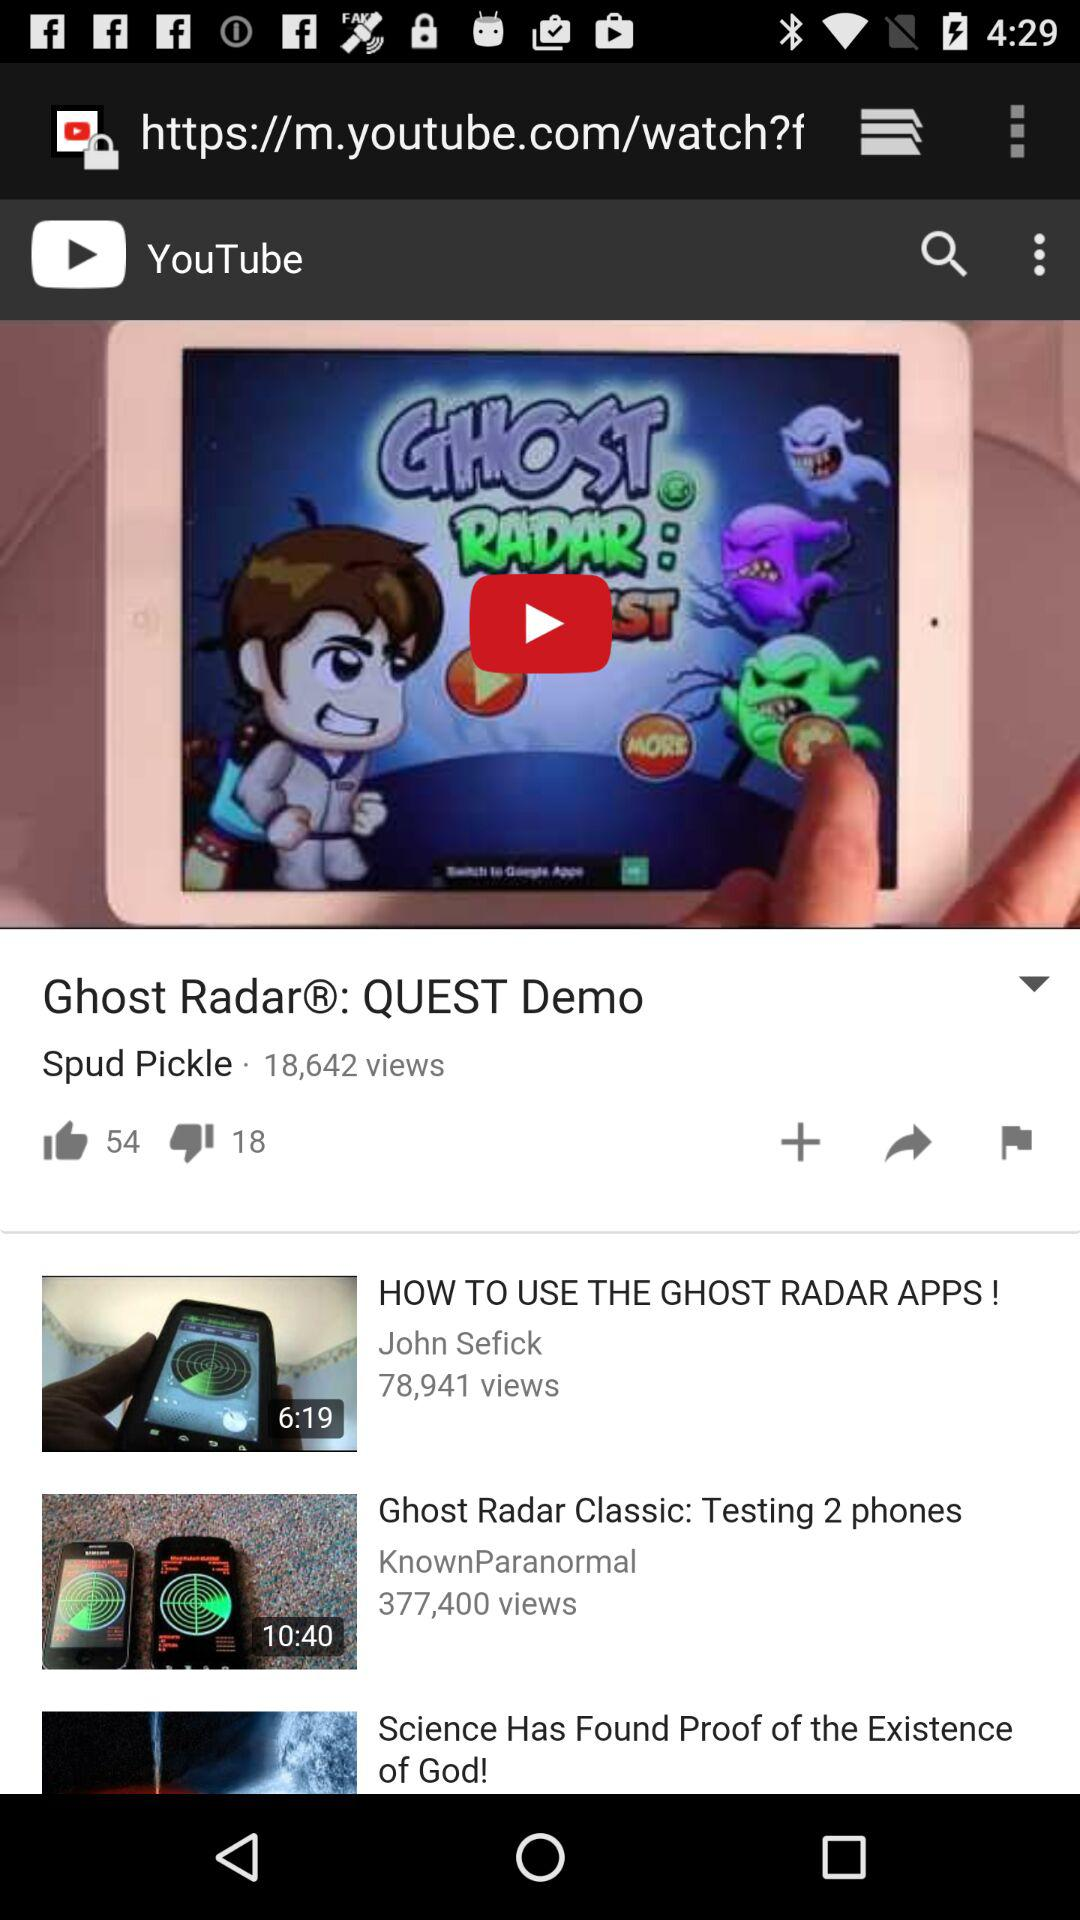How many more thumbs up than thumbs down does the video "Ghost Radar®: QUEST Demo" have?
Answer the question using a single word or phrase. 36 